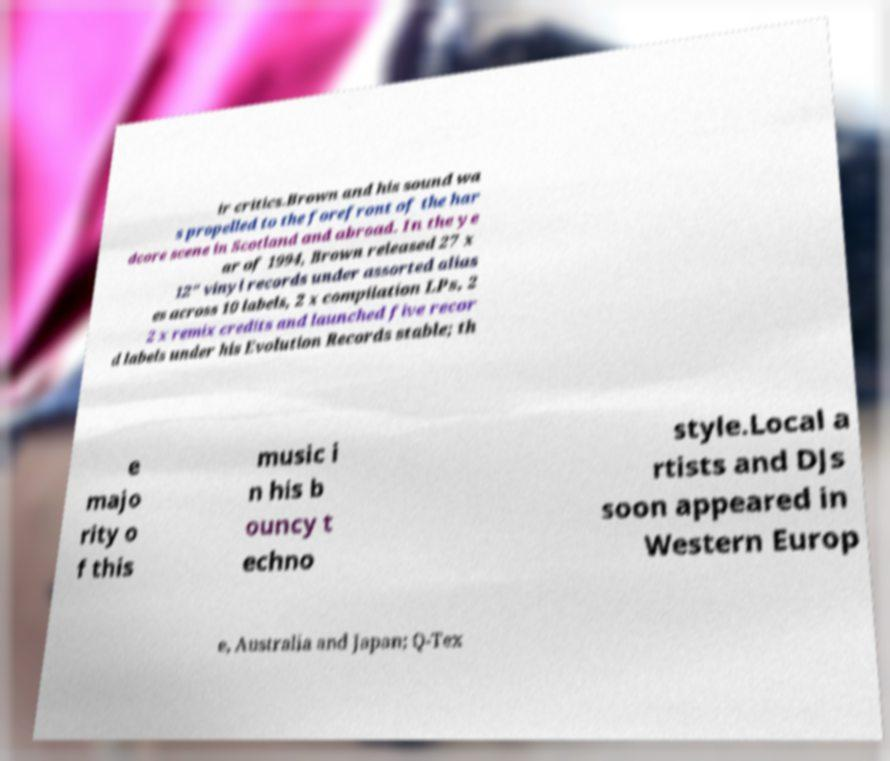Could you assist in decoding the text presented in this image and type it out clearly? ir critics.Brown and his sound wa s propelled to the forefront of the har dcore scene in Scotland and abroad. In the ye ar of 1994, Brown released 27 x 12" vinyl records under assorted alias es across 10 labels, 2 x compilation LPs, 2 2 x remix credits and launched five recor d labels under his Evolution Records stable; th e majo rity o f this music i n his b ouncy t echno style.Local a rtists and DJs soon appeared in Western Europ e, Australia and Japan; Q-Tex 